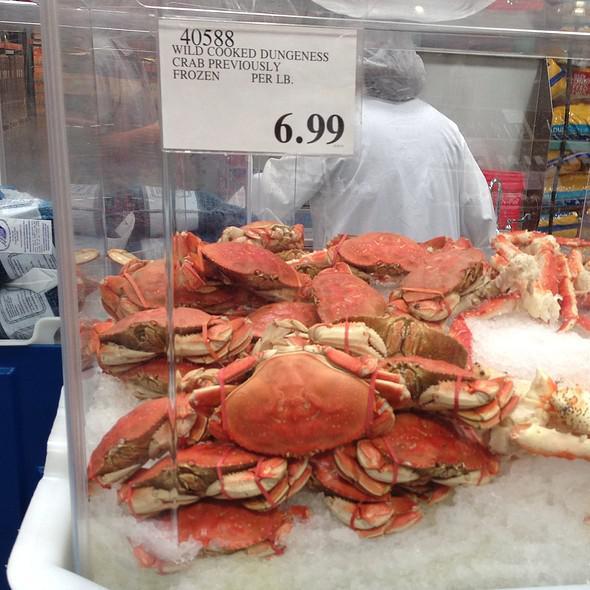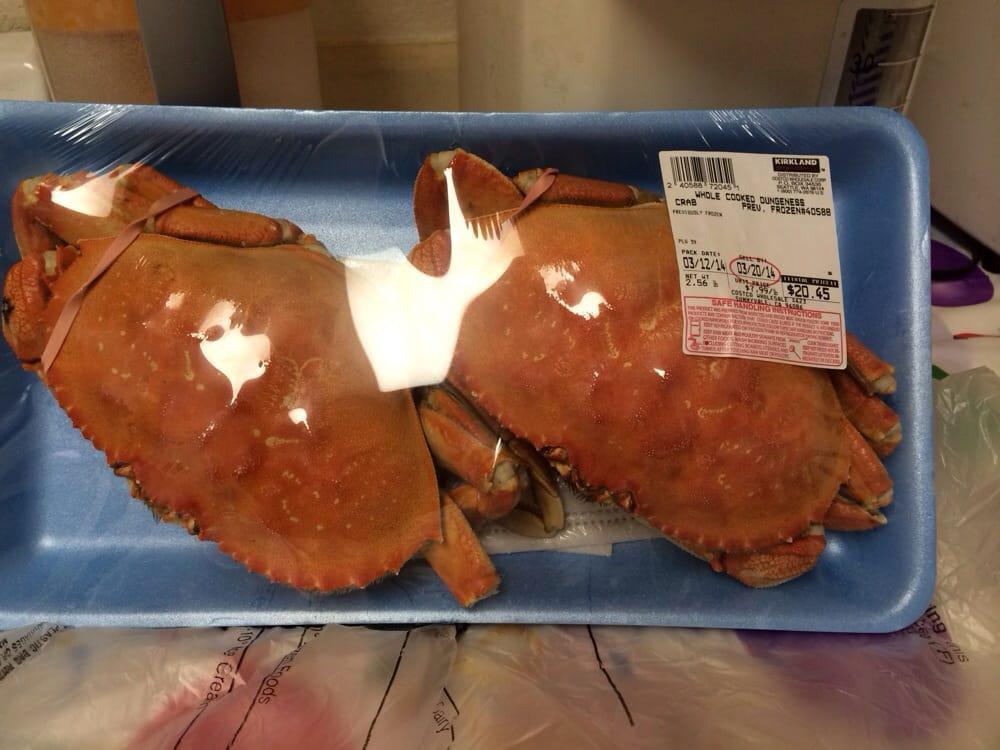The first image is the image on the left, the second image is the image on the right. Analyze the images presented: Is the assertion "There is a single package of two crabs in an image." valid? Answer yes or no. Yes. The first image is the image on the left, the second image is the image on the right. Analyze the images presented: Is the assertion "In at least one image there is a total two crabs wrap in a single blue and plastic container." valid? Answer yes or no. Yes. 